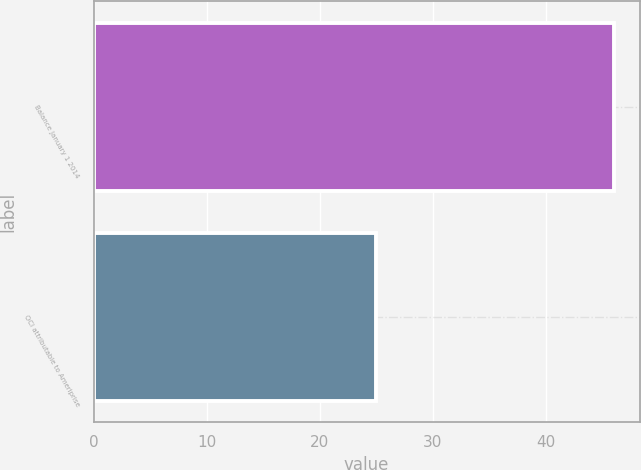<chart> <loc_0><loc_0><loc_500><loc_500><bar_chart><fcel>Balance January 1 2014<fcel>OCI attributable to Ameriprise<nl><fcel>46<fcel>25<nl></chart> 